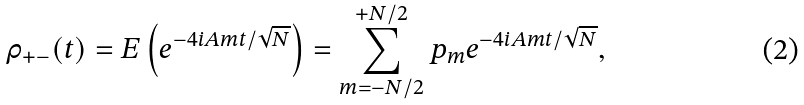<formula> <loc_0><loc_0><loc_500><loc_500>\rho _ { + - } ( t ) = { E } \left ( e ^ { - 4 i A m t / \sqrt { N } } \right ) = \sum _ { m = - N / 2 } ^ { + N / 2 } p _ { m } e ^ { - 4 i A m t / \sqrt { N } } ,</formula> 